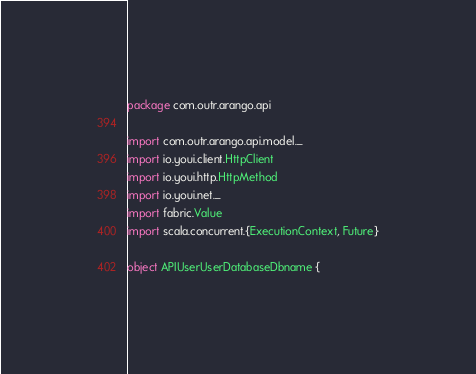Convert code to text. <code><loc_0><loc_0><loc_500><loc_500><_Scala_>package com.outr.arango.api

import com.outr.arango.api.model._
import io.youi.client.HttpClient
import io.youi.http.HttpMethod
import io.youi.net._
import fabric.Value
import scala.concurrent.{ExecutionContext, Future}
      
object APIUserUserDatabaseDbname {
</code> 